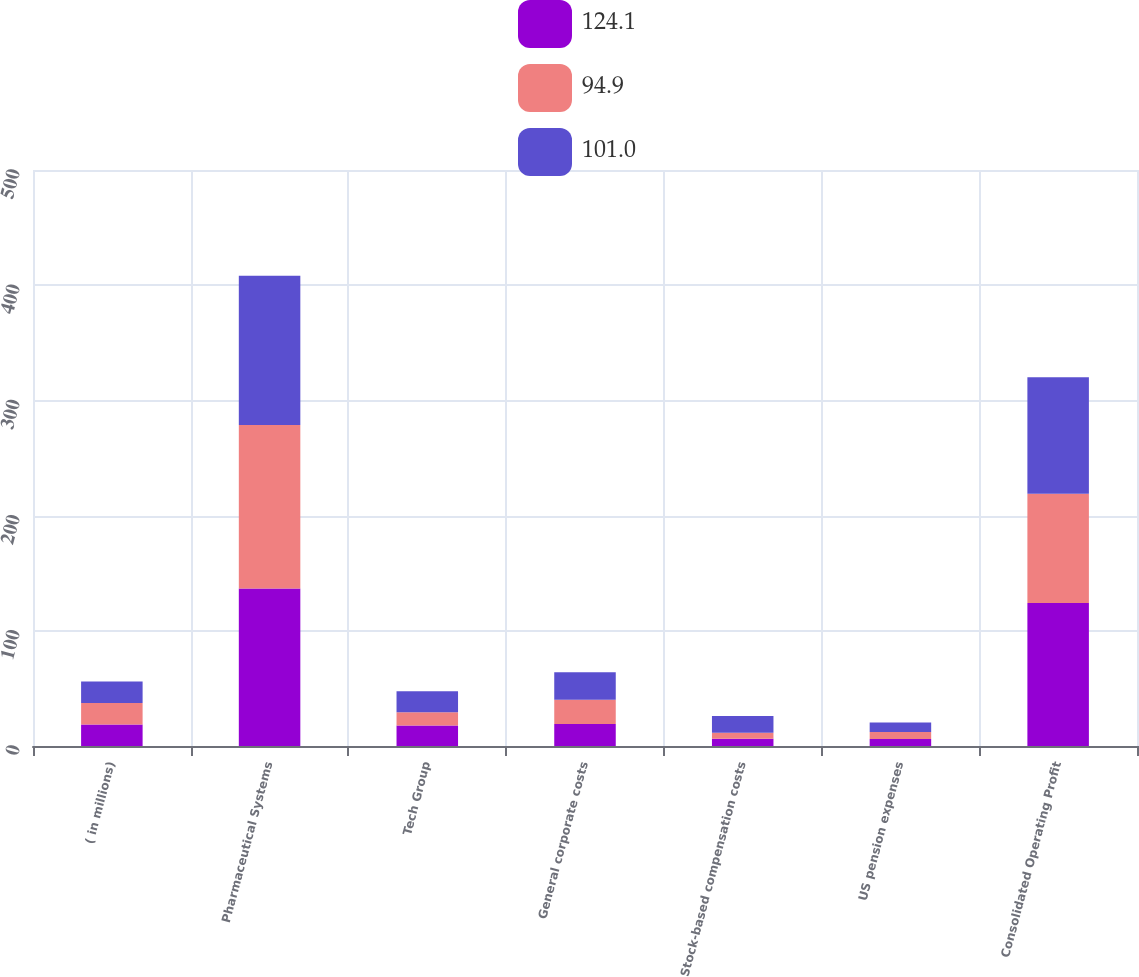Convert chart to OTSL. <chart><loc_0><loc_0><loc_500><loc_500><stacked_bar_chart><ecel><fcel>( in millions)<fcel>Pharmaceutical Systems<fcel>Tech Group<fcel>General corporate costs<fcel>Stock-based compensation costs<fcel>US pension expenses<fcel>Consolidated Operating Profit<nl><fcel>124.1<fcel>18.65<fcel>136.7<fcel>17.8<fcel>19.2<fcel>6.4<fcel>6<fcel>124.1<nl><fcel>94.9<fcel>18.65<fcel>141.9<fcel>11.6<fcel>21<fcel>5.1<fcel>6.1<fcel>94.9<nl><fcel>101<fcel>18.65<fcel>129.7<fcel>18.1<fcel>23.9<fcel>14.5<fcel>8.4<fcel>101<nl></chart> 